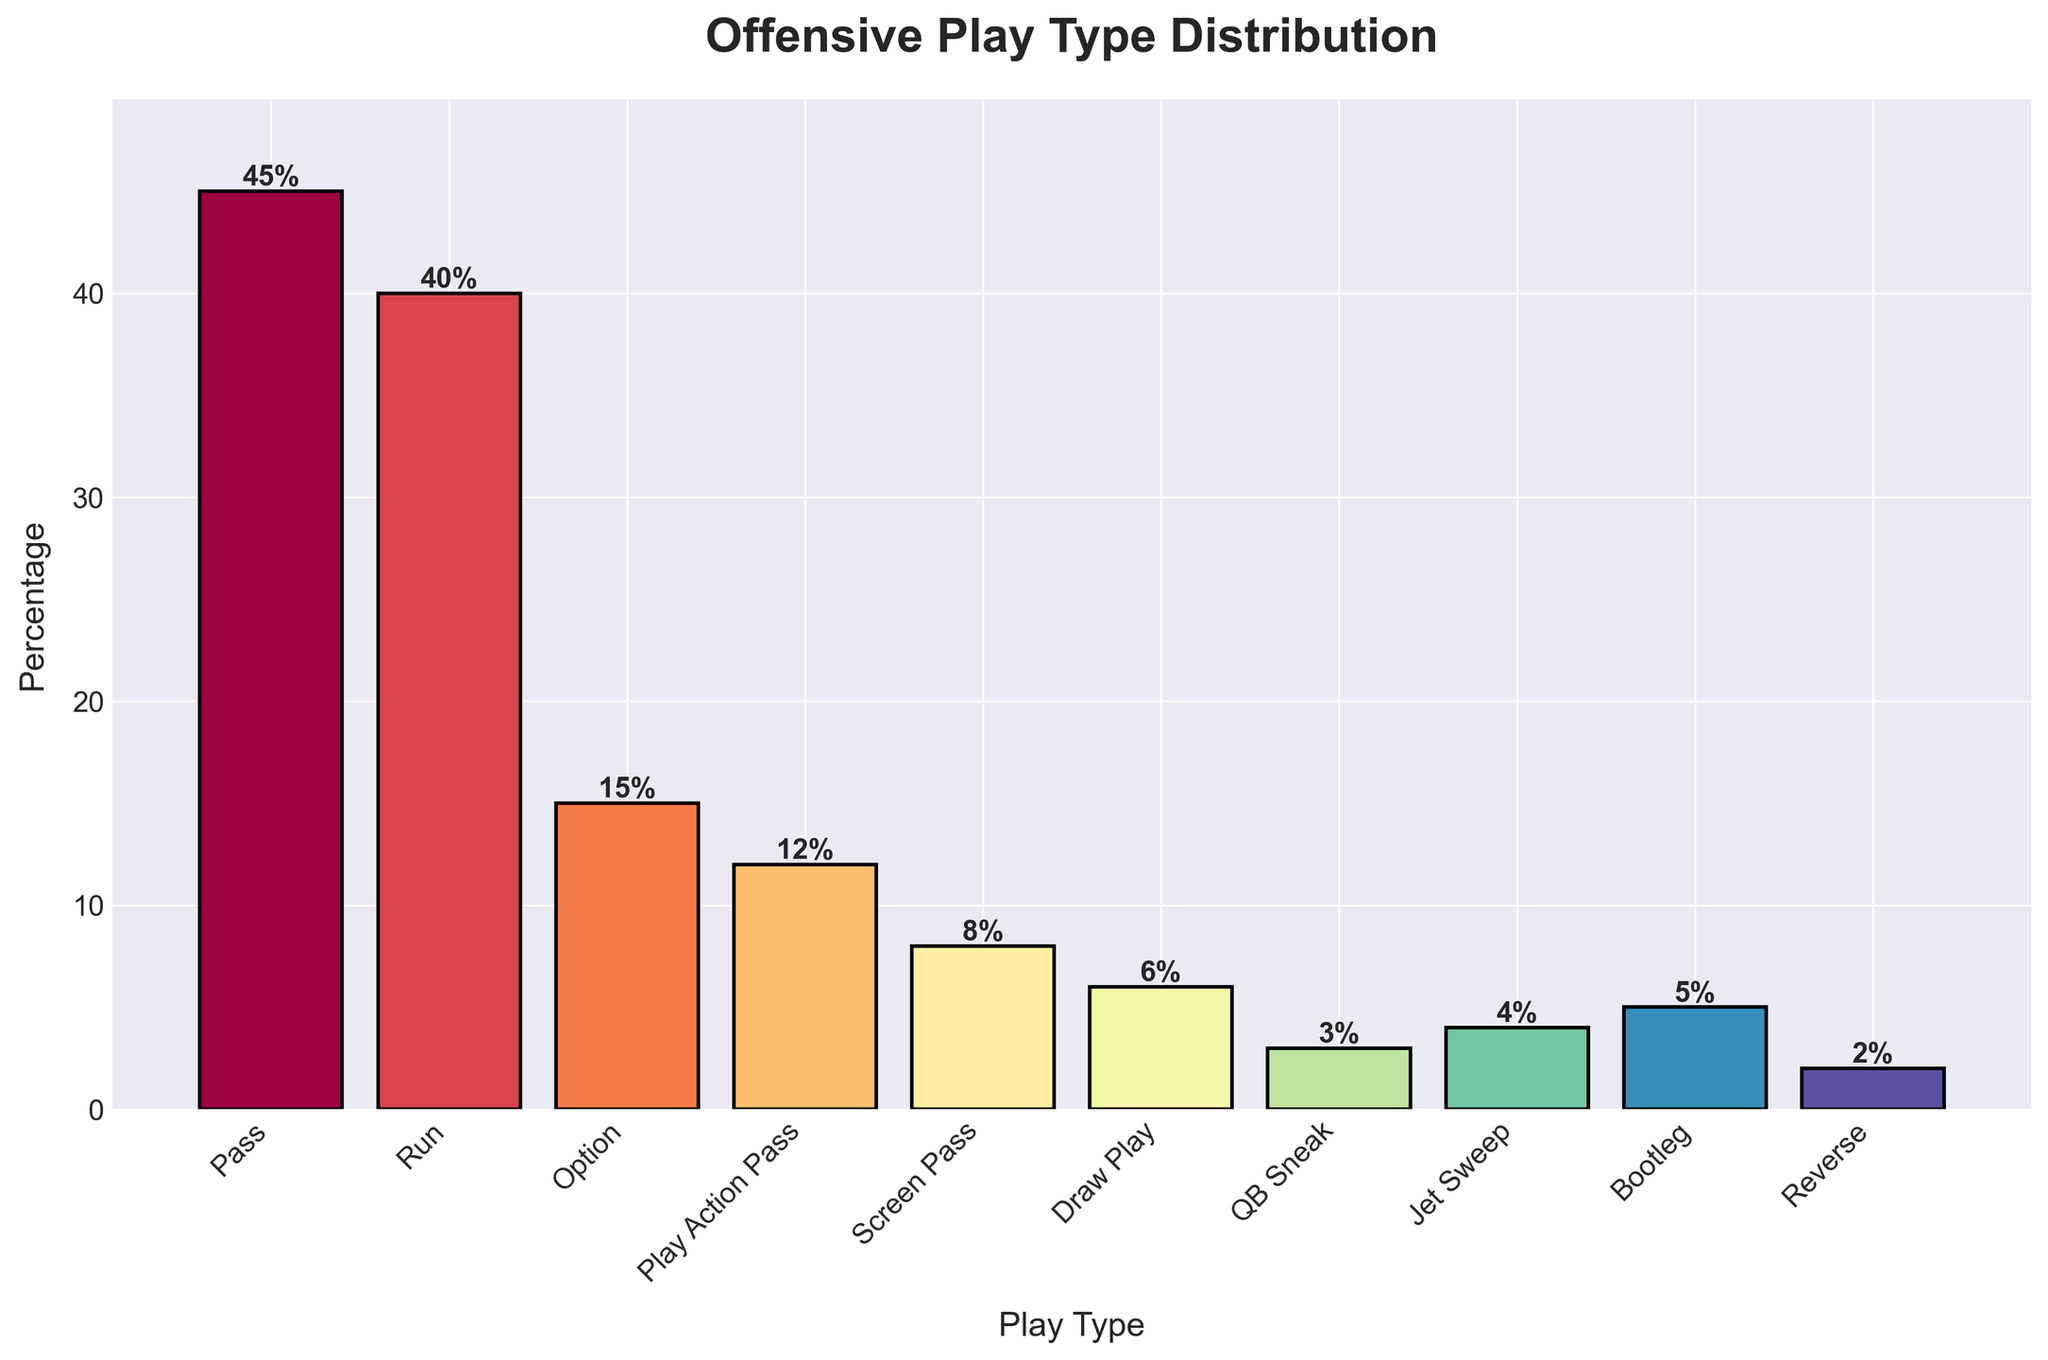What is the most common offensive play type? The tallest bar represents the play type with the highest percentage. The bar for "Pass" is the tallest, indicating it is the most common offensive play type.
Answer: Pass Which play type is used the least? The shortest bar represents the play type with the lowest percentage. The "Reverse" bar is the shortest, indicating it is the least used play type.
Answer: Reverse How much more is the percentage of "Pass" play type compared to "Option"? Find the heights of the "Pass" and "Option" bars. The height of "Pass" is 45%, and the height of "Option" is 15%. The difference is 45% - 15%.
Answer: 30% What is the combined percentage of all pass-related play types? Identify all pass-related types: "Pass", "Play Action Pass", and "Screen Pass". Sum their percentages: 45% (Pass) + 12% (Play Action Pass) + 8% (Screen Pass) = 65%.
Answer: 65% Which play type has a percentage exactly half of the "Run" play type? Find half the height of the "Run" bar: 40% / 2 = 20%. Check if any bar matches this percentage. None of the play types match 20%, so none has exactly half the percentage of "Run".
Answer: None What is the difference in percentage between the "Run" and "Jet Sweep" play types? Find the heights of the "Run" and "Jet Sweep" bars. The height of "Run" is 40%, and the height of "Jet Sweep" is 4%. The difference is 40% - 4%.
Answer: 36% Which play type is the third most common? Arrange the bars from tallest to shortest. The third tallest bar corresponds to the "Option" play type with 15%.
Answer: Option What is the average percentage of "Draw Play", "QB Sneak", and "Reverse"? Sum the percentages of "Draw Play", "QB Sneak", and "Reverse": 6% + 3% + 2% = 11%. Divide by the number of play types: 11% / 3.
Answer: 3.67% How do the percentages of the top two play types compare visually? The top two play types are "Pass" (45%) and "Run" (40%). Observing the bar heights, the "Pass" bar is slightly taller than the "Run" bar.
Answer: Pass is slightly taller than Run What is the percentage difference between the combined pass plays and all remaining play types? Combined pass-related plays sum to 65%. Remaining play types are: "Run" (40%), "Option" (15%), "Draw Play" (6%), "QB Sneak" (3%), "Jet Sweep" (4%), "Bootleg" (5%), "Reverse" (2%). Sum is 75%. The difference is 75% - 65%.
Answer: 10% 